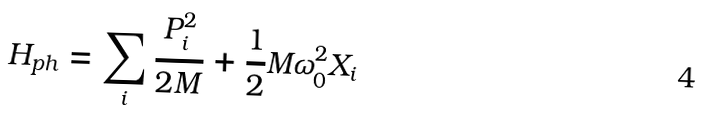<formula> <loc_0><loc_0><loc_500><loc_500>H _ { p h } = \sum _ { i } \frac { P ^ { 2 } _ { i } } { 2 M } + \frac { 1 } { 2 } M \omega ^ { 2 } _ { 0 } X _ { i }</formula> 